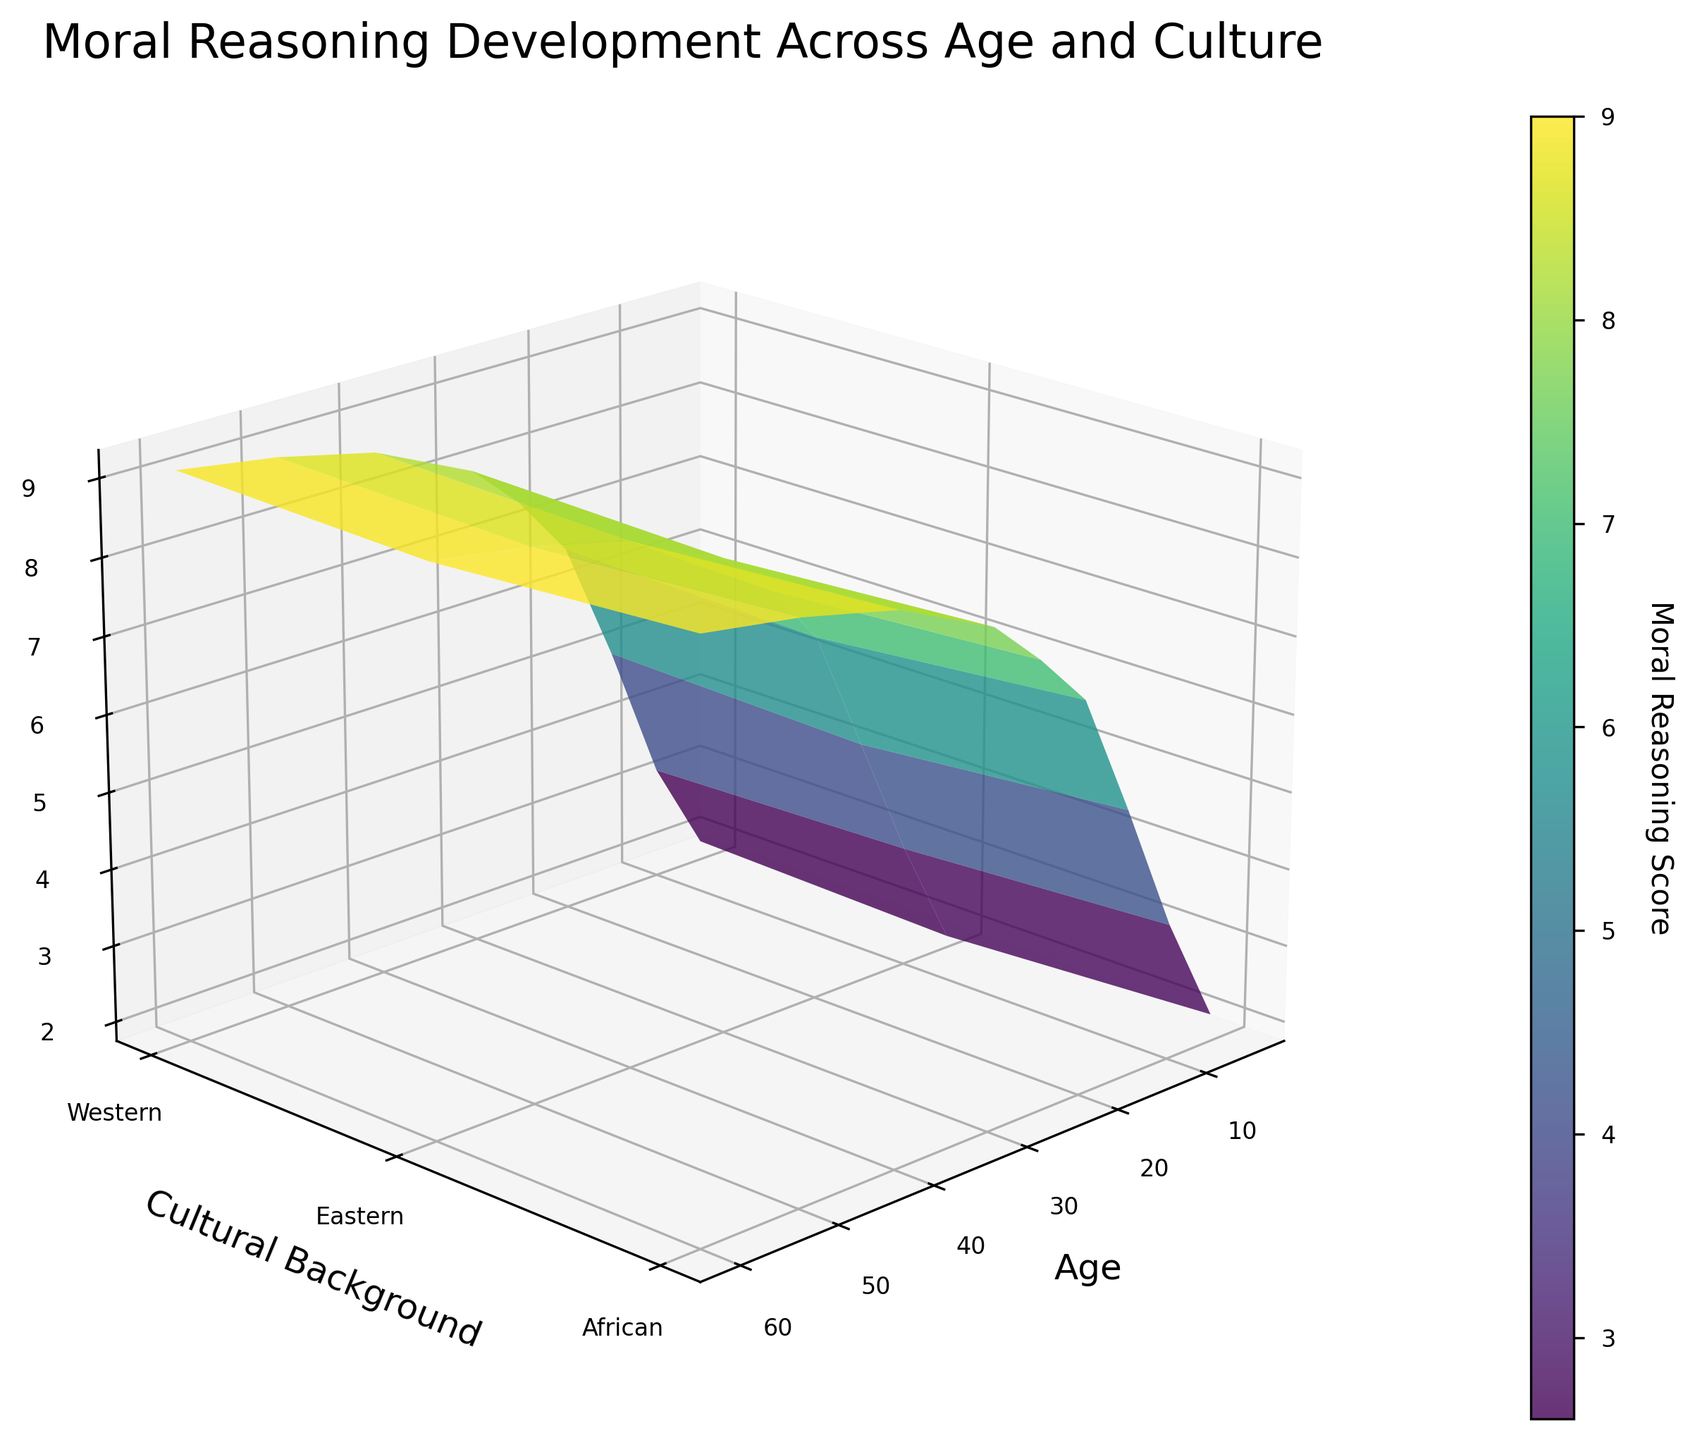What are the variables represented on the axes? The x-axis represents Age, the y-axis represents Cultural Background, and the z-axis represents the Moral Reasoning Score.
Answer: Age, Cultural Background, Moral Reasoning Score Which age group has the highest Moral Reasoning Score across all cultural backgrounds? By visually inspecting the highest points on the z-axis across all cultural backgrounds, the age group 60 has the highest scores.
Answer: 60 What is the general trend of Moral Reasoning Score as age increases for Western culture? By observing the surface plot for the Western cultural background from left to right as age increases, the z-values (Moral Reasoning Scores) consistently increase.
Answer: Increases How does the Moral Reasoning Score for African culture compare between the age groups 10 and 50? By comparing the z-values for African culture at age 10 and age 50, age 10 has a score of 3.2, and age 50 has a score of 8.9.
Answer: Score increases from 3.2 to 8.9 Which cultural background shows the smallest variation in Moral Reasoning Score across different age groups? Observe the range of the z-values for each cultural background. The Eastern cultural background shows the smallest variation, with scores ranging from 1.9 to 9.0.
Answer: Eastern Is there any cultural background where Moral Reasoning Scores plateau at certain ages? By visually inspecting the plateaus of the surface for each cultural background, it appears that the Western cultural background has a plateau in scores at ages 50 to 60 around the values 9.0 to 9.2.
Answer: Western What is the average Moral Reasoning Score for all cultural backgrounds at age 20? Sum the z-values for each cultural background at age 20 and divide by three, (6.8 + 6.5 + 6.6) / 3 = 6.63.
Answer: 6.63 Do any cultural backgrounds intersect in terms of Moral Reasoning Score across different ages? By closely observing the surface plot's intersections across ages, it is noted that Western and African cultural backgrounds intersect around ages 15 and 60.
Answer: Yes Which cultural background has the highest increase in Moral Reasoning Score from age 5 to age 60? Calculate the difference in z-values for each cultural background and identify the highest increase: 
Western: 9.2 - 2.1 = 7.1,
Eastern: 9.0 - 1.9 = 7.1,
African: 9.1 - 2.0 = 7.1.
All three have the maximum increase of 7.1.
Answer: All three How does the surface plot visual indicate the relationship between age and moral reasoning development? The surface plot shows higher z-values (Moral Reasoning Scores) with increasing x-values (Age), indicating a positive relationship between age and moral reasoning development.
Answer: Positive relationship 